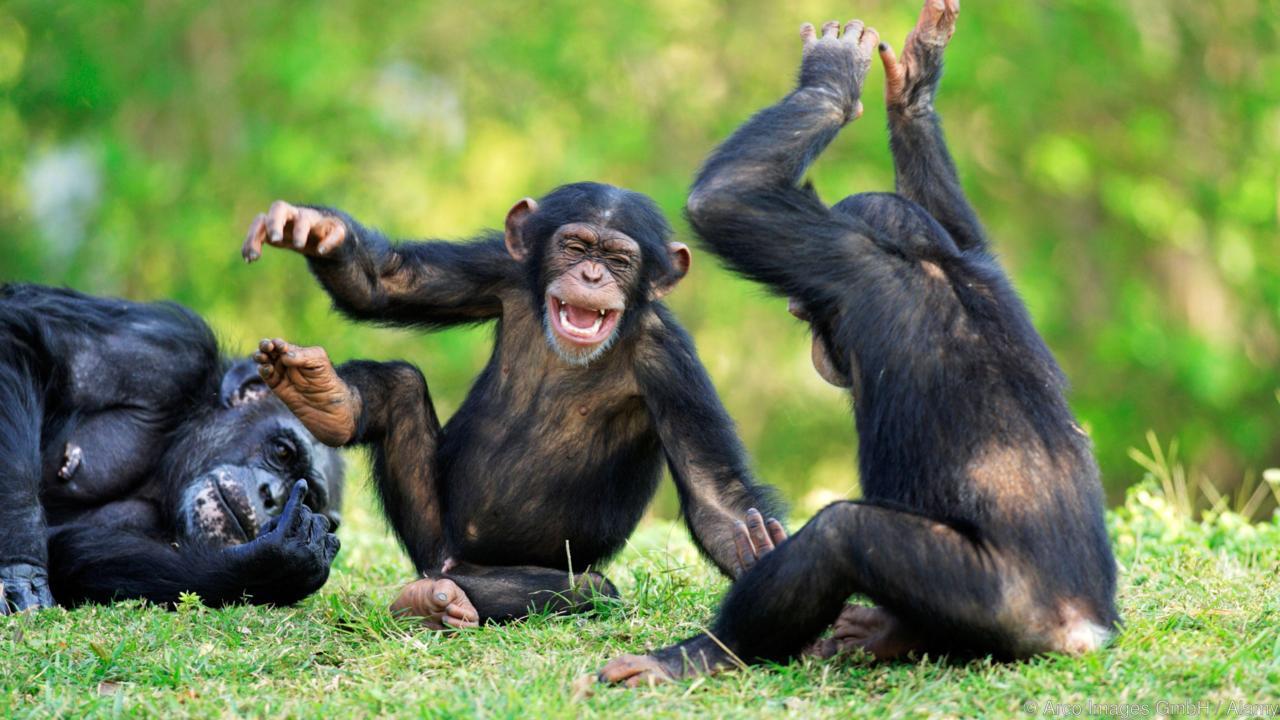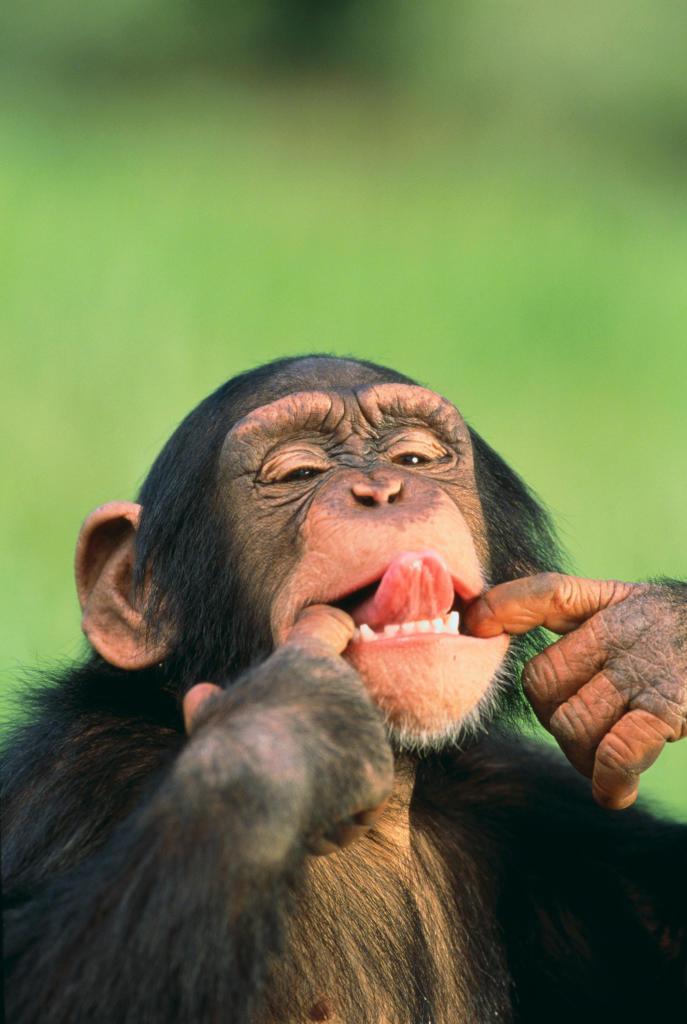The first image is the image on the left, the second image is the image on the right. Assess this claim about the two images: "There are two monkeys in the image on the right.". Correct or not? Answer yes or no. No. 